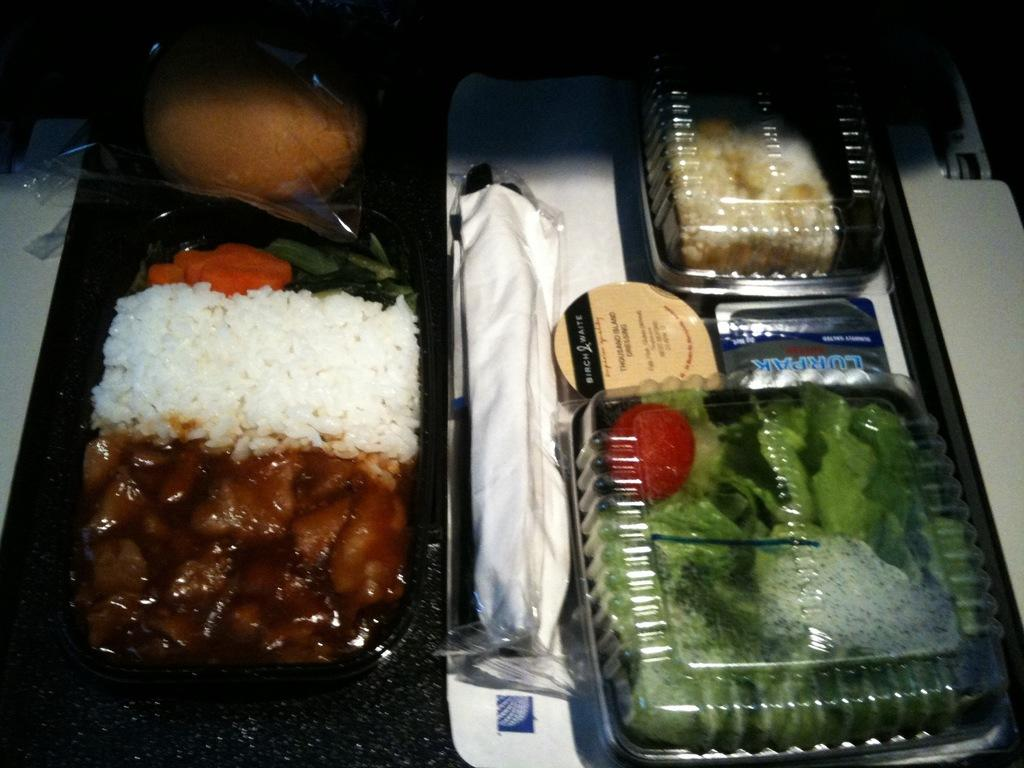<image>
Describe the image concisely. The thousand island dressing on an airline's in flight meal is by Birch & White. 